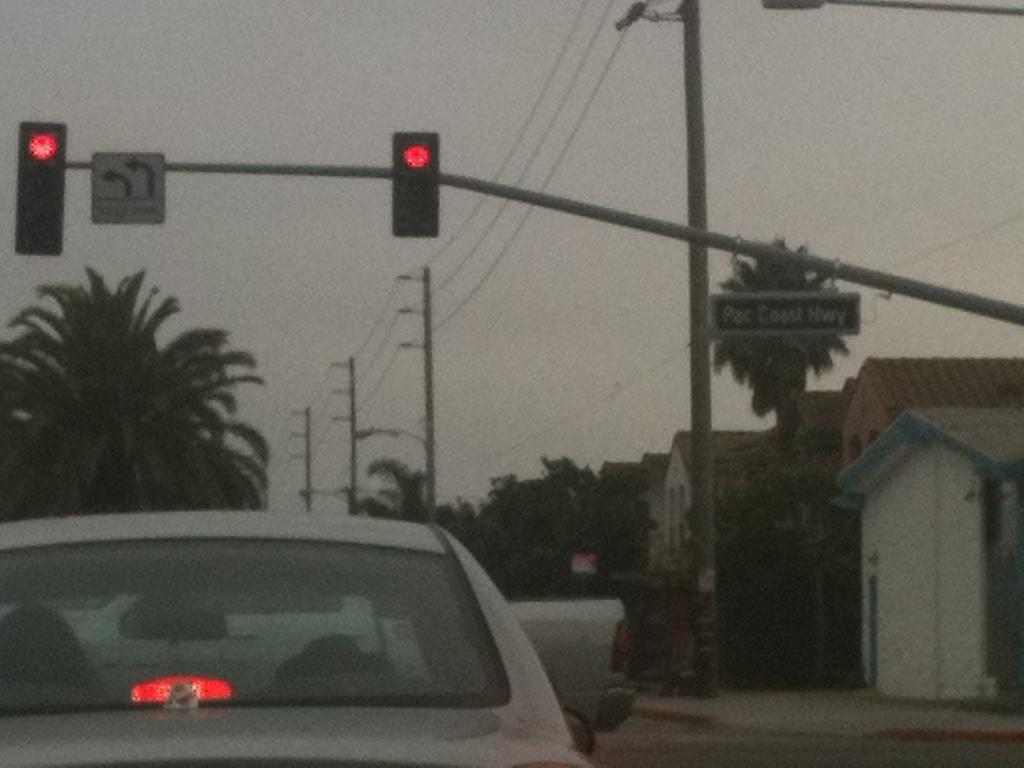<image>
Create a compact narrative representing the image presented. A green sign for Pac Coast HWY is posted on the traffic light. 